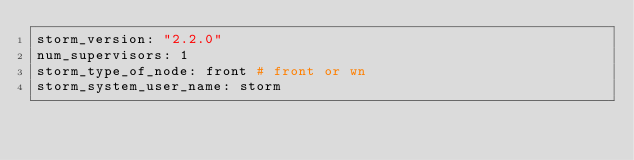Convert code to text. <code><loc_0><loc_0><loc_500><loc_500><_YAML_>storm_version: "2.2.0"
num_supervisors: 1
storm_type_of_node: front # front or wn
storm_system_user_name: storm</code> 